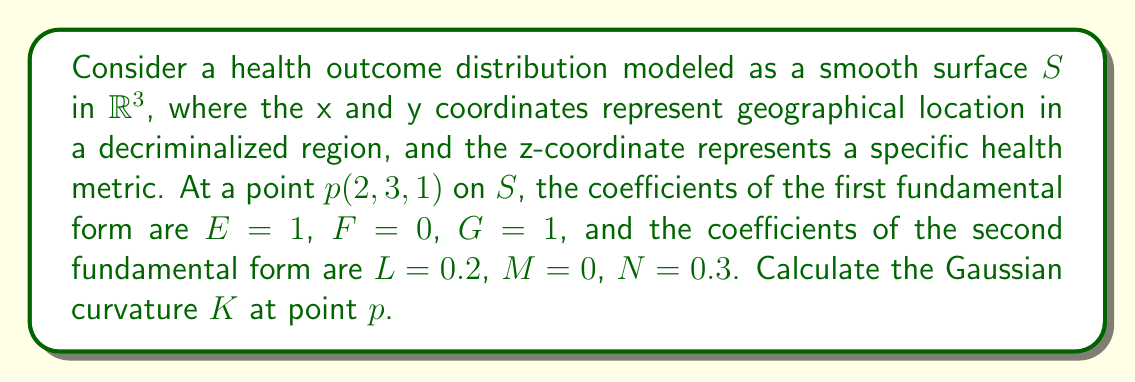Can you solve this math problem? To calculate the Gaussian curvature at point $p$, we'll follow these steps:

1) Recall that the Gaussian curvature $K$ is defined as:

   $$K = \frac{LN - M^2}{EG - F^2}$$

   where $E$, $F$, $G$ are coefficients of the first fundamental form, and $L$, $M$, $N$ are coefficients of the second fundamental form.

2) We're given:
   $E = 1$, $F = 0$, $G = 1$
   $L = 0.2$, $M = 0$, $N = 0.3$

3) Let's calculate the numerator $(LN - M^2)$:
   $$LN - M^2 = (0.2)(0.3) - 0^2 = 0.06$$

4) Now, let's calculate the denominator $(EG - F^2)$:
   $$EG - F^2 = (1)(1) - 0^2 = 1$$

5) Therefore, the Gaussian curvature $K$ is:

   $$K = \frac{LN - M^2}{EG - F^2} = \frac{0.06}{1} = 0.06$$

Thus, the Gaussian curvature at point $p$ is 0.06.
Answer: $K = 0.06$ 